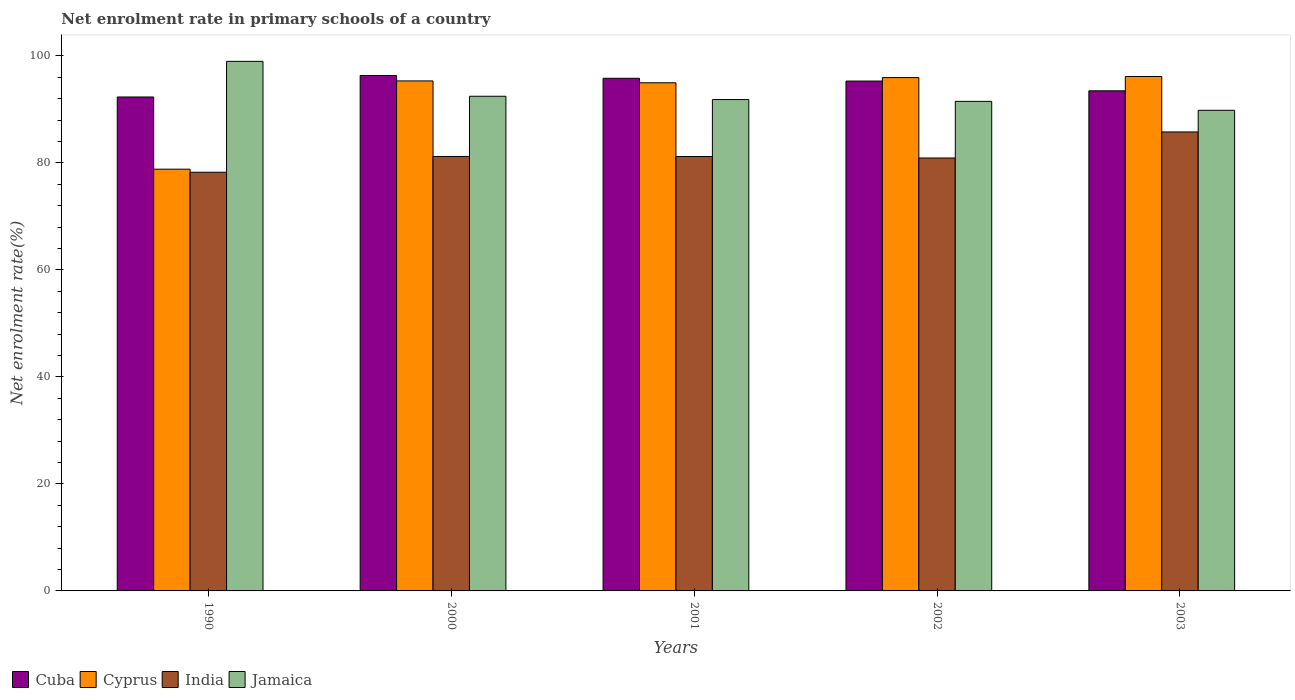How many groups of bars are there?
Make the answer very short. 5. Are the number of bars per tick equal to the number of legend labels?
Ensure brevity in your answer.  Yes. In how many cases, is the number of bars for a given year not equal to the number of legend labels?
Provide a succinct answer. 0. What is the net enrolment rate in primary schools in India in 2003?
Ensure brevity in your answer.  85.78. Across all years, what is the maximum net enrolment rate in primary schools in India?
Your answer should be compact. 85.78. Across all years, what is the minimum net enrolment rate in primary schools in Jamaica?
Your response must be concise. 89.83. In which year was the net enrolment rate in primary schools in Cuba maximum?
Give a very brief answer. 2000. In which year was the net enrolment rate in primary schools in Cuba minimum?
Make the answer very short. 1990. What is the total net enrolment rate in primary schools in Cuba in the graph?
Provide a succinct answer. 473.22. What is the difference between the net enrolment rate in primary schools in Cyprus in 1990 and that in 2001?
Ensure brevity in your answer.  -16.15. What is the difference between the net enrolment rate in primary schools in Cuba in 2000 and the net enrolment rate in primary schools in Cyprus in 1990?
Your response must be concise. 17.51. What is the average net enrolment rate in primary schools in India per year?
Offer a terse response. 81.47. In the year 2002, what is the difference between the net enrolment rate in primary schools in India and net enrolment rate in primary schools in Cuba?
Your answer should be compact. -14.38. What is the ratio of the net enrolment rate in primary schools in Cyprus in 1990 to that in 2001?
Your answer should be very brief. 0.83. What is the difference between the highest and the second highest net enrolment rate in primary schools in Cuba?
Your answer should be very brief. 0.52. What is the difference between the highest and the lowest net enrolment rate in primary schools in Jamaica?
Your answer should be very brief. 9.15. In how many years, is the net enrolment rate in primary schools in India greater than the average net enrolment rate in primary schools in India taken over all years?
Offer a terse response. 1. Is the sum of the net enrolment rate in primary schools in Jamaica in 1990 and 2001 greater than the maximum net enrolment rate in primary schools in Cyprus across all years?
Your answer should be very brief. Yes. Is it the case that in every year, the sum of the net enrolment rate in primary schools in Jamaica and net enrolment rate in primary schools in Cuba is greater than the sum of net enrolment rate in primary schools in India and net enrolment rate in primary schools in Cyprus?
Keep it short and to the point. No. What does the 3rd bar from the left in 1990 represents?
Provide a succinct answer. India. What does the 3rd bar from the right in 2000 represents?
Your response must be concise. Cyprus. Are all the bars in the graph horizontal?
Your answer should be very brief. No. How many years are there in the graph?
Your response must be concise. 5. Does the graph contain any zero values?
Keep it short and to the point. No. Where does the legend appear in the graph?
Provide a short and direct response. Bottom left. How many legend labels are there?
Provide a short and direct response. 4. How are the legend labels stacked?
Keep it short and to the point. Horizontal. What is the title of the graph?
Your answer should be very brief. Net enrolment rate in primary schools of a country. What is the label or title of the X-axis?
Offer a terse response. Years. What is the label or title of the Y-axis?
Make the answer very short. Net enrolment rate(%). What is the Net enrolment rate(%) of Cuba in 1990?
Your answer should be very brief. 92.31. What is the Net enrolment rate(%) of Cyprus in 1990?
Your answer should be very brief. 78.82. What is the Net enrolment rate(%) in India in 1990?
Give a very brief answer. 78.25. What is the Net enrolment rate(%) of Jamaica in 1990?
Offer a very short reply. 98.97. What is the Net enrolment rate(%) in Cuba in 2000?
Give a very brief answer. 96.33. What is the Net enrolment rate(%) of Cyprus in 2000?
Make the answer very short. 95.32. What is the Net enrolment rate(%) in India in 2000?
Your response must be concise. 81.2. What is the Net enrolment rate(%) of Jamaica in 2000?
Provide a succinct answer. 92.45. What is the Net enrolment rate(%) of Cuba in 2001?
Make the answer very short. 95.81. What is the Net enrolment rate(%) in Cyprus in 2001?
Your answer should be very brief. 94.97. What is the Net enrolment rate(%) of India in 2001?
Your answer should be compact. 81.19. What is the Net enrolment rate(%) of Jamaica in 2001?
Offer a very short reply. 91.83. What is the Net enrolment rate(%) in Cuba in 2002?
Your response must be concise. 95.29. What is the Net enrolment rate(%) of Cyprus in 2002?
Your response must be concise. 95.94. What is the Net enrolment rate(%) of India in 2002?
Your answer should be compact. 80.91. What is the Net enrolment rate(%) of Jamaica in 2002?
Keep it short and to the point. 91.49. What is the Net enrolment rate(%) of Cuba in 2003?
Ensure brevity in your answer.  93.47. What is the Net enrolment rate(%) of Cyprus in 2003?
Offer a terse response. 96.14. What is the Net enrolment rate(%) of India in 2003?
Provide a succinct answer. 85.78. What is the Net enrolment rate(%) in Jamaica in 2003?
Keep it short and to the point. 89.83. Across all years, what is the maximum Net enrolment rate(%) in Cuba?
Your response must be concise. 96.33. Across all years, what is the maximum Net enrolment rate(%) of Cyprus?
Give a very brief answer. 96.14. Across all years, what is the maximum Net enrolment rate(%) of India?
Make the answer very short. 85.78. Across all years, what is the maximum Net enrolment rate(%) of Jamaica?
Offer a terse response. 98.97. Across all years, what is the minimum Net enrolment rate(%) in Cuba?
Make the answer very short. 92.31. Across all years, what is the minimum Net enrolment rate(%) of Cyprus?
Ensure brevity in your answer.  78.82. Across all years, what is the minimum Net enrolment rate(%) of India?
Your answer should be compact. 78.25. Across all years, what is the minimum Net enrolment rate(%) of Jamaica?
Offer a terse response. 89.83. What is the total Net enrolment rate(%) of Cuba in the graph?
Make the answer very short. 473.22. What is the total Net enrolment rate(%) in Cyprus in the graph?
Give a very brief answer. 461.2. What is the total Net enrolment rate(%) of India in the graph?
Your answer should be compact. 407.33. What is the total Net enrolment rate(%) of Jamaica in the graph?
Offer a very short reply. 464.58. What is the difference between the Net enrolment rate(%) in Cuba in 1990 and that in 2000?
Your answer should be very brief. -4.02. What is the difference between the Net enrolment rate(%) in Cyprus in 1990 and that in 2000?
Keep it short and to the point. -16.5. What is the difference between the Net enrolment rate(%) of India in 1990 and that in 2000?
Ensure brevity in your answer.  -2.95. What is the difference between the Net enrolment rate(%) in Jamaica in 1990 and that in 2000?
Your answer should be compact. 6.52. What is the difference between the Net enrolment rate(%) in Cuba in 1990 and that in 2001?
Give a very brief answer. -3.49. What is the difference between the Net enrolment rate(%) of Cyprus in 1990 and that in 2001?
Your answer should be very brief. -16.15. What is the difference between the Net enrolment rate(%) of India in 1990 and that in 2001?
Keep it short and to the point. -2.94. What is the difference between the Net enrolment rate(%) of Jamaica in 1990 and that in 2001?
Offer a terse response. 7.14. What is the difference between the Net enrolment rate(%) of Cuba in 1990 and that in 2002?
Your response must be concise. -2.98. What is the difference between the Net enrolment rate(%) of Cyprus in 1990 and that in 2002?
Provide a short and direct response. -17.12. What is the difference between the Net enrolment rate(%) in India in 1990 and that in 2002?
Make the answer very short. -2.66. What is the difference between the Net enrolment rate(%) of Jamaica in 1990 and that in 2002?
Give a very brief answer. 7.48. What is the difference between the Net enrolment rate(%) of Cuba in 1990 and that in 2003?
Offer a terse response. -1.16. What is the difference between the Net enrolment rate(%) in Cyprus in 1990 and that in 2003?
Provide a short and direct response. -17.32. What is the difference between the Net enrolment rate(%) in India in 1990 and that in 2003?
Your response must be concise. -7.53. What is the difference between the Net enrolment rate(%) in Jamaica in 1990 and that in 2003?
Give a very brief answer. 9.15. What is the difference between the Net enrolment rate(%) in Cuba in 2000 and that in 2001?
Your answer should be very brief. 0.52. What is the difference between the Net enrolment rate(%) of Cyprus in 2000 and that in 2001?
Your response must be concise. 0.35. What is the difference between the Net enrolment rate(%) in India in 2000 and that in 2001?
Your answer should be compact. 0.01. What is the difference between the Net enrolment rate(%) of Jamaica in 2000 and that in 2001?
Offer a terse response. 0.62. What is the difference between the Net enrolment rate(%) of Cuba in 2000 and that in 2002?
Provide a succinct answer. 1.04. What is the difference between the Net enrolment rate(%) of Cyprus in 2000 and that in 2002?
Your answer should be compact. -0.62. What is the difference between the Net enrolment rate(%) of India in 2000 and that in 2002?
Your answer should be very brief. 0.28. What is the difference between the Net enrolment rate(%) in Jamaica in 2000 and that in 2002?
Offer a very short reply. 0.96. What is the difference between the Net enrolment rate(%) in Cuba in 2000 and that in 2003?
Provide a short and direct response. 2.86. What is the difference between the Net enrolment rate(%) of Cyprus in 2000 and that in 2003?
Give a very brief answer. -0.82. What is the difference between the Net enrolment rate(%) of India in 2000 and that in 2003?
Your answer should be compact. -4.58. What is the difference between the Net enrolment rate(%) of Jamaica in 2000 and that in 2003?
Your answer should be compact. 2.62. What is the difference between the Net enrolment rate(%) in Cuba in 2001 and that in 2002?
Keep it short and to the point. 0.52. What is the difference between the Net enrolment rate(%) in Cyprus in 2001 and that in 2002?
Offer a very short reply. -0.97. What is the difference between the Net enrolment rate(%) of India in 2001 and that in 2002?
Offer a terse response. 0.28. What is the difference between the Net enrolment rate(%) of Jamaica in 2001 and that in 2002?
Provide a short and direct response. 0.34. What is the difference between the Net enrolment rate(%) in Cuba in 2001 and that in 2003?
Your answer should be compact. 2.34. What is the difference between the Net enrolment rate(%) in Cyprus in 2001 and that in 2003?
Ensure brevity in your answer.  -1.17. What is the difference between the Net enrolment rate(%) in India in 2001 and that in 2003?
Give a very brief answer. -4.59. What is the difference between the Net enrolment rate(%) in Jamaica in 2001 and that in 2003?
Offer a terse response. 2. What is the difference between the Net enrolment rate(%) of Cuba in 2002 and that in 2003?
Provide a succinct answer. 1.82. What is the difference between the Net enrolment rate(%) of Cyprus in 2002 and that in 2003?
Give a very brief answer. -0.2. What is the difference between the Net enrolment rate(%) of India in 2002 and that in 2003?
Your response must be concise. -4.87. What is the difference between the Net enrolment rate(%) in Jamaica in 2002 and that in 2003?
Your answer should be compact. 1.67. What is the difference between the Net enrolment rate(%) in Cuba in 1990 and the Net enrolment rate(%) in Cyprus in 2000?
Give a very brief answer. -3. What is the difference between the Net enrolment rate(%) of Cuba in 1990 and the Net enrolment rate(%) of India in 2000?
Provide a succinct answer. 11.12. What is the difference between the Net enrolment rate(%) in Cuba in 1990 and the Net enrolment rate(%) in Jamaica in 2000?
Your answer should be very brief. -0.14. What is the difference between the Net enrolment rate(%) in Cyprus in 1990 and the Net enrolment rate(%) in India in 2000?
Your answer should be very brief. -2.38. What is the difference between the Net enrolment rate(%) in Cyprus in 1990 and the Net enrolment rate(%) in Jamaica in 2000?
Provide a short and direct response. -13.63. What is the difference between the Net enrolment rate(%) in India in 1990 and the Net enrolment rate(%) in Jamaica in 2000?
Offer a very short reply. -14.2. What is the difference between the Net enrolment rate(%) of Cuba in 1990 and the Net enrolment rate(%) of Cyprus in 2001?
Offer a very short reply. -2.66. What is the difference between the Net enrolment rate(%) of Cuba in 1990 and the Net enrolment rate(%) of India in 2001?
Your response must be concise. 11.12. What is the difference between the Net enrolment rate(%) of Cuba in 1990 and the Net enrolment rate(%) of Jamaica in 2001?
Offer a very short reply. 0.48. What is the difference between the Net enrolment rate(%) of Cyprus in 1990 and the Net enrolment rate(%) of India in 2001?
Keep it short and to the point. -2.37. What is the difference between the Net enrolment rate(%) of Cyprus in 1990 and the Net enrolment rate(%) of Jamaica in 2001?
Keep it short and to the point. -13.01. What is the difference between the Net enrolment rate(%) of India in 1990 and the Net enrolment rate(%) of Jamaica in 2001?
Your answer should be very brief. -13.58. What is the difference between the Net enrolment rate(%) of Cuba in 1990 and the Net enrolment rate(%) of Cyprus in 2002?
Offer a very short reply. -3.63. What is the difference between the Net enrolment rate(%) in Cuba in 1990 and the Net enrolment rate(%) in India in 2002?
Provide a short and direct response. 11.4. What is the difference between the Net enrolment rate(%) of Cuba in 1990 and the Net enrolment rate(%) of Jamaica in 2002?
Make the answer very short. 0.82. What is the difference between the Net enrolment rate(%) in Cyprus in 1990 and the Net enrolment rate(%) in India in 2002?
Give a very brief answer. -2.09. What is the difference between the Net enrolment rate(%) of Cyprus in 1990 and the Net enrolment rate(%) of Jamaica in 2002?
Provide a succinct answer. -12.67. What is the difference between the Net enrolment rate(%) in India in 1990 and the Net enrolment rate(%) in Jamaica in 2002?
Make the answer very short. -13.25. What is the difference between the Net enrolment rate(%) of Cuba in 1990 and the Net enrolment rate(%) of Cyprus in 2003?
Ensure brevity in your answer.  -3.83. What is the difference between the Net enrolment rate(%) in Cuba in 1990 and the Net enrolment rate(%) in India in 2003?
Provide a short and direct response. 6.53. What is the difference between the Net enrolment rate(%) in Cuba in 1990 and the Net enrolment rate(%) in Jamaica in 2003?
Your response must be concise. 2.49. What is the difference between the Net enrolment rate(%) in Cyprus in 1990 and the Net enrolment rate(%) in India in 2003?
Your answer should be very brief. -6.96. What is the difference between the Net enrolment rate(%) in Cyprus in 1990 and the Net enrolment rate(%) in Jamaica in 2003?
Provide a succinct answer. -11.01. What is the difference between the Net enrolment rate(%) in India in 1990 and the Net enrolment rate(%) in Jamaica in 2003?
Offer a terse response. -11.58. What is the difference between the Net enrolment rate(%) in Cuba in 2000 and the Net enrolment rate(%) in Cyprus in 2001?
Ensure brevity in your answer.  1.36. What is the difference between the Net enrolment rate(%) of Cuba in 2000 and the Net enrolment rate(%) of India in 2001?
Make the answer very short. 15.14. What is the difference between the Net enrolment rate(%) of Cuba in 2000 and the Net enrolment rate(%) of Jamaica in 2001?
Offer a terse response. 4.5. What is the difference between the Net enrolment rate(%) in Cyprus in 2000 and the Net enrolment rate(%) in India in 2001?
Provide a succinct answer. 14.13. What is the difference between the Net enrolment rate(%) of Cyprus in 2000 and the Net enrolment rate(%) of Jamaica in 2001?
Your answer should be very brief. 3.49. What is the difference between the Net enrolment rate(%) of India in 2000 and the Net enrolment rate(%) of Jamaica in 2001?
Your answer should be very brief. -10.63. What is the difference between the Net enrolment rate(%) in Cuba in 2000 and the Net enrolment rate(%) in Cyprus in 2002?
Ensure brevity in your answer.  0.39. What is the difference between the Net enrolment rate(%) in Cuba in 2000 and the Net enrolment rate(%) in India in 2002?
Offer a terse response. 15.42. What is the difference between the Net enrolment rate(%) of Cuba in 2000 and the Net enrolment rate(%) of Jamaica in 2002?
Your answer should be very brief. 4.84. What is the difference between the Net enrolment rate(%) in Cyprus in 2000 and the Net enrolment rate(%) in India in 2002?
Ensure brevity in your answer.  14.4. What is the difference between the Net enrolment rate(%) in Cyprus in 2000 and the Net enrolment rate(%) in Jamaica in 2002?
Make the answer very short. 3.82. What is the difference between the Net enrolment rate(%) in India in 2000 and the Net enrolment rate(%) in Jamaica in 2002?
Give a very brief answer. -10.3. What is the difference between the Net enrolment rate(%) in Cuba in 2000 and the Net enrolment rate(%) in Cyprus in 2003?
Offer a very short reply. 0.19. What is the difference between the Net enrolment rate(%) of Cuba in 2000 and the Net enrolment rate(%) of India in 2003?
Ensure brevity in your answer.  10.55. What is the difference between the Net enrolment rate(%) of Cuba in 2000 and the Net enrolment rate(%) of Jamaica in 2003?
Offer a terse response. 6.5. What is the difference between the Net enrolment rate(%) of Cyprus in 2000 and the Net enrolment rate(%) of India in 2003?
Provide a short and direct response. 9.54. What is the difference between the Net enrolment rate(%) of Cyprus in 2000 and the Net enrolment rate(%) of Jamaica in 2003?
Offer a very short reply. 5.49. What is the difference between the Net enrolment rate(%) in India in 2000 and the Net enrolment rate(%) in Jamaica in 2003?
Make the answer very short. -8.63. What is the difference between the Net enrolment rate(%) of Cuba in 2001 and the Net enrolment rate(%) of Cyprus in 2002?
Provide a short and direct response. -0.13. What is the difference between the Net enrolment rate(%) in Cuba in 2001 and the Net enrolment rate(%) in India in 2002?
Your response must be concise. 14.89. What is the difference between the Net enrolment rate(%) of Cuba in 2001 and the Net enrolment rate(%) of Jamaica in 2002?
Offer a very short reply. 4.31. What is the difference between the Net enrolment rate(%) in Cyprus in 2001 and the Net enrolment rate(%) in India in 2002?
Your response must be concise. 14.06. What is the difference between the Net enrolment rate(%) in Cyprus in 2001 and the Net enrolment rate(%) in Jamaica in 2002?
Your answer should be very brief. 3.48. What is the difference between the Net enrolment rate(%) of India in 2001 and the Net enrolment rate(%) of Jamaica in 2002?
Your answer should be compact. -10.3. What is the difference between the Net enrolment rate(%) in Cuba in 2001 and the Net enrolment rate(%) in Cyprus in 2003?
Your response must be concise. -0.33. What is the difference between the Net enrolment rate(%) in Cuba in 2001 and the Net enrolment rate(%) in India in 2003?
Your response must be concise. 10.03. What is the difference between the Net enrolment rate(%) of Cuba in 2001 and the Net enrolment rate(%) of Jamaica in 2003?
Provide a short and direct response. 5.98. What is the difference between the Net enrolment rate(%) of Cyprus in 2001 and the Net enrolment rate(%) of India in 2003?
Make the answer very short. 9.19. What is the difference between the Net enrolment rate(%) of Cyprus in 2001 and the Net enrolment rate(%) of Jamaica in 2003?
Your answer should be compact. 5.14. What is the difference between the Net enrolment rate(%) of India in 2001 and the Net enrolment rate(%) of Jamaica in 2003?
Provide a succinct answer. -8.64. What is the difference between the Net enrolment rate(%) of Cuba in 2002 and the Net enrolment rate(%) of Cyprus in 2003?
Provide a succinct answer. -0.85. What is the difference between the Net enrolment rate(%) of Cuba in 2002 and the Net enrolment rate(%) of India in 2003?
Offer a terse response. 9.51. What is the difference between the Net enrolment rate(%) of Cuba in 2002 and the Net enrolment rate(%) of Jamaica in 2003?
Make the answer very short. 5.46. What is the difference between the Net enrolment rate(%) of Cyprus in 2002 and the Net enrolment rate(%) of India in 2003?
Your answer should be compact. 10.16. What is the difference between the Net enrolment rate(%) in Cyprus in 2002 and the Net enrolment rate(%) in Jamaica in 2003?
Your response must be concise. 6.11. What is the difference between the Net enrolment rate(%) in India in 2002 and the Net enrolment rate(%) in Jamaica in 2003?
Your answer should be compact. -8.91. What is the average Net enrolment rate(%) of Cuba per year?
Provide a succinct answer. 94.64. What is the average Net enrolment rate(%) of Cyprus per year?
Offer a very short reply. 92.24. What is the average Net enrolment rate(%) in India per year?
Give a very brief answer. 81.47. What is the average Net enrolment rate(%) of Jamaica per year?
Ensure brevity in your answer.  92.92. In the year 1990, what is the difference between the Net enrolment rate(%) of Cuba and Net enrolment rate(%) of Cyprus?
Provide a succinct answer. 13.49. In the year 1990, what is the difference between the Net enrolment rate(%) in Cuba and Net enrolment rate(%) in India?
Your answer should be very brief. 14.06. In the year 1990, what is the difference between the Net enrolment rate(%) in Cuba and Net enrolment rate(%) in Jamaica?
Provide a succinct answer. -6.66. In the year 1990, what is the difference between the Net enrolment rate(%) of Cyprus and Net enrolment rate(%) of India?
Offer a terse response. 0.57. In the year 1990, what is the difference between the Net enrolment rate(%) in Cyprus and Net enrolment rate(%) in Jamaica?
Ensure brevity in your answer.  -20.15. In the year 1990, what is the difference between the Net enrolment rate(%) in India and Net enrolment rate(%) in Jamaica?
Make the answer very short. -20.73. In the year 2000, what is the difference between the Net enrolment rate(%) in Cuba and Net enrolment rate(%) in Cyprus?
Keep it short and to the point. 1.01. In the year 2000, what is the difference between the Net enrolment rate(%) in Cuba and Net enrolment rate(%) in India?
Give a very brief answer. 15.13. In the year 2000, what is the difference between the Net enrolment rate(%) in Cuba and Net enrolment rate(%) in Jamaica?
Your answer should be very brief. 3.88. In the year 2000, what is the difference between the Net enrolment rate(%) of Cyprus and Net enrolment rate(%) of India?
Offer a very short reply. 14.12. In the year 2000, what is the difference between the Net enrolment rate(%) of Cyprus and Net enrolment rate(%) of Jamaica?
Give a very brief answer. 2.87. In the year 2000, what is the difference between the Net enrolment rate(%) in India and Net enrolment rate(%) in Jamaica?
Keep it short and to the point. -11.25. In the year 2001, what is the difference between the Net enrolment rate(%) of Cuba and Net enrolment rate(%) of Cyprus?
Make the answer very short. 0.84. In the year 2001, what is the difference between the Net enrolment rate(%) of Cuba and Net enrolment rate(%) of India?
Your response must be concise. 14.62. In the year 2001, what is the difference between the Net enrolment rate(%) in Cuba and Net enrolment rate(%) in Jamaica?
Your response must be concise. 3.98. In the year 2001, what is the difference between the Net enrolment rate(%) of Cyprus and Net enrolment rate(%) of India?
Ensure brevity in your answer.  13.78. In the year 2001, what is the difference between the Net enrolment rate(%) in Cyprus and Net enrolment rate(%) in Jamaica?
Give a very brief answer. 3.14. In the year 2001, what is the difference between the Net enrolment rate(%) of India and Net enrolment rate(%) of Jamaica?
Your answer should be very brief. -10.64. In the year 2002, what is the difference between the Net enrolment rate(%) of Cuba and Net enrolment rate(%) of Cyprus?
Make the answer very short. -0.65. In the year 2002, what is the difference between the Net enrolment rate(%) in Cuba and Net enrolment rate(%) in India?
Offer a very short reply. 14.38. In the year 2002, what is the difference between the Net enrolment rate(%) in Cuba and Net enrolment rate(%) in Jamaica?
Provide a short and direct response. 3.8. In the year 2002, what is the difference between the Net enrolment rate(%) of Cyprus and Net enrolment rate(%) of India?
Offer a terse response. 15.03. In the year 2002, what is the difference between the Net enrolment rate(%) of Cyprus and Net enrolment rate(%) of Jamaica?
Give a very brief answer. 4.45. In the year 2002, what is the difference between the Net enrolment rate(%) of India and Net enrolment rate(%) of Jamaica?
Keep it short and to the point. -10.58. In the year 2003, what is the difference between the Net enrolment rate(%) of Cuba and Net enrolment rate(%) of Cyprus?
Give a very brief answer. -2.67. In the year 2003, what is the difference between the Net enrolment rate(%) in Cuba and Net enrolment rate(%) in India?
Your answer should be compact. 7.69. In the year 2003, what is the difference between the Net enrolment rate(%) in Cuba and Net enrolment rate(%) in Jamaica?
Make the answer very short. 3.64. In the year 2003, what is the difference between the Net enrolment rate(%) in Cyprus and Net enrolment rate(%) in India?
Offer a terse response. 10.36. In the year 2003, what is the difference between the Net enrolment rate(%) in Cyprus and Net enrolment rate(%) in Jamaica?
Make the answer very short. 6.31. In the year 2003, what is the difference between the Net enrolment rate(%) of India and Net enrolment rate(%) of Jamaica?
Offer a very short reply. -4.05. What is the ratio of the Net enrolment rate(%) in Cyprus in 1990 to that in 2000?
Make the answer very short. 0.83. What is the ratio of the Net enrolment rate(%) of India in 1990 to that in 2000?
Offer a terse response. 0.96. What is the ratio of the Net enrolment rate(%) in Jamaica in 1990 to that in 2000?
Offer a very short reply. 1.07. What is the ratio of the Net enrolment rate(%) of Cuba in 1990 to that in 2001?
Ensure brevity in your answer.  0.96. What is the ratio of the Net enrolment rate(%) in Cyprus in 1990 to that in 2001?
Make the answer very short. 0.83. What is the ratio of the Net enrolment rate(%) in India in 1990 to that in 2001?
Offer a very short reply. 0.96. What is the ratio of the Net enrolment rate(%) in Jamaica in 1990 to that in 2001?
Make the answer very short. 1.08. What is the ratio of the Net enrolment rate(%) in Cuba in 1990 to that in 2002?
Give a very brief answer. 0.97. What is the ratio of the Net enrolment rate(%) in Cyprus in 1990 to that in 2002?
Your answer should be compact. 0.82. What is the ratio of the Net enrolment rate(%) of India in 1990 to that in 2002?
Make the answer very short. 0.97. What is the ratio of the Net enrolment rate(%) of Jamaica in 1990 to that in 2002?
Provide a succinct answer. 1.08. What is the ratio of the Net enrolment rate(%) of Cuba in 1990 to that in 2003?
Make the answer very short. 0.99. What is the ratio of the Net enrolment rate(%) of Cyprus in 1990 to that in 2003?
Offer a terse response. 0.82. What is the ratio of the Net enrolment rate(%) of India in 1990 to that in 2003?
Provide a short and direct response. 0.91. What is the ratio of the Net enrolment rate(%) in Jamaica in 1990 to that in 2003?
Ensure brevity in your answer.  1.1. What is the ratio of the Net enrolment rate(%) of Cuba in 2000 to that in 2001?
Give a very brief answer. 1.01. What is the ratio of the Net enrolment rate(%) of India in 2000 to that in 2001?
Provide a short and direct response. 1. What is the ratio of the Net enrolment rate(%) in Jamaica in 2000 to that in 2001?
Offer a very short reply. 1.01. What is the ratio of the Net enrolment rate(%) of Cuba in 2000 to that in 2002?
Provide a succinct answer. 1.01. What is the ratio of the Net enrolment rate(%) of Cyprus in 2000 to that in 2002?
Your response must be concise. 0.99. What is the ratio of the Net enrolment rate(%) of Jamaica in 2000 to that in 2002?
Keep it short and to the point. 1.01. What is the ratio of the Net enrolment rate(%) in Cuba in 2000 to that in 2003?
Your answer should be compact. 1.03. What is the ratio of the Net enrolment rate(%) in Cyprus in 2000 to that in 2003?
Provide a succinct answer. 0.99. What is the ratio of the Net enrolment rate(%) of India in 2000 to that in 2003?
Make the answer very short. 0.95. What is the ratio of the Net enrolment rate(%) of Jamaica in 2000 to that in 2003?
Your answer should be compact. 1.03. What is the ratio of the Net enrolment rate(%) in Cuba in 2001 to that in 2002?
Keep it short and to the point. 1.01. What is the ratio of the Net enrolment rate(%) in Cyprus in 2001 to that in 2002?
Provide a succinct answer. 0.99. What is the ratio of the Net enrolment rate(%) of India in 2001 to that in 2002?
Your response must be concise. 1. What is the ratio of the Net enrolment rate(%) in Jamaica in 2001 to that in 2002?
Offer a terse response. 1. What is the ratio of the Net enrolment rate(%) of Cuba in 2001 to that in 2003?
Offer a terse response. 1.02. What is the ratio of the Net enrolment rate(%) in India in 2001 to that in 2003?
Your response must be concise. 0.95. What is the ratio of the Net enrolment rate(%) of Jamaica in 2001 to that in 2003?
Provide a short and direct response. 1.02. What is the ratio of the Net enrolment rate(%) in Cuba in 2002 to that in 2003?
Your answer should be very brief. 1.02. What is the ratio of the Net enrolment rate(%) in Cyprus in 2002 to that in 2003?
Keep it short and to the point. 1. What is the ratio of the Net enrolment rate(%) in India in 2002 to that in 2003?
Make the answer very short. 0.94. What is the ratio of the Net enrolment rate(%) of Jamaica in 2002 to that in 2003?
Ensure brevity in your answer.  1.02. What is the difference between the highest and the second highest Net enrolment rate(%) of Cuba?
Provide a succinct answer. 0.52. What is the difference between the highest and the second highest Net enrolment rate(%) of Cyprus?
Give a very brief answer. 0.2. What is the difference between the highest and the second highest Net enrolment rate(%) in India?
Your answer should be very brief. 4.58. What is the difference between the highest and the second highest Net enrolment rate(%) of Jamaica?
Offer a terse response. 6.52. What is the difference between the highest and the lowest Net enrolment rate(%) of Cuba?
Provide a succinct answer. 4.02. What is the difference between the highest and the lowest Net enrolment rate(%) of Cyprus?
Give a very brief answer. 17.32. What is the difference between the highest and the lowest Net enrolment rate(%) of India?
Your response must be concise. 7.53. What is the difference between the highest and the lowest Net enrolment rate(%) of Jamaica?
Your answer should be compact. 9.15. 